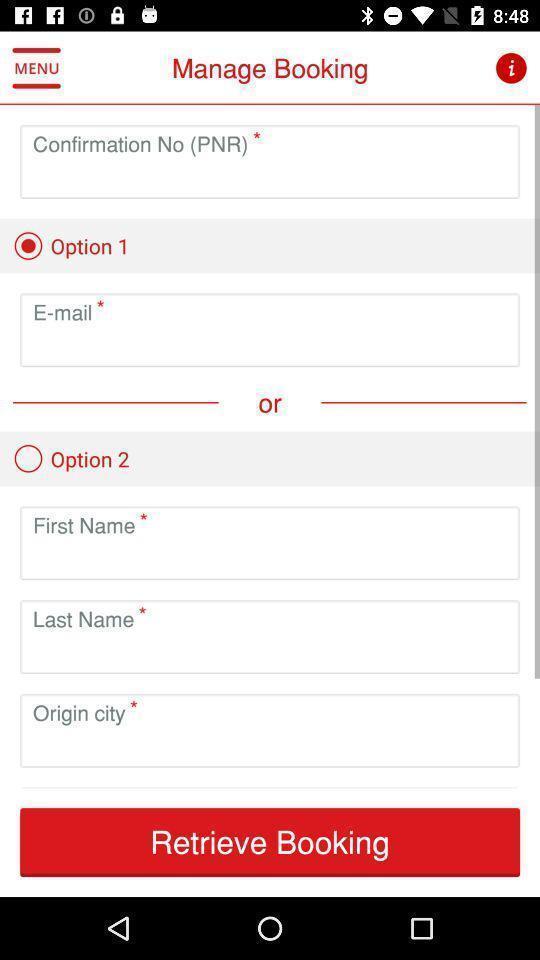What details can you identify in this image? Screen showing manage booking page in a travel app. 